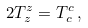<formula> <loc_0><loc_0><loc_500><loc_500>2 { T _ { z } ^ { z } } = { T _ { c } ^ { c } } \, ,</formula> 